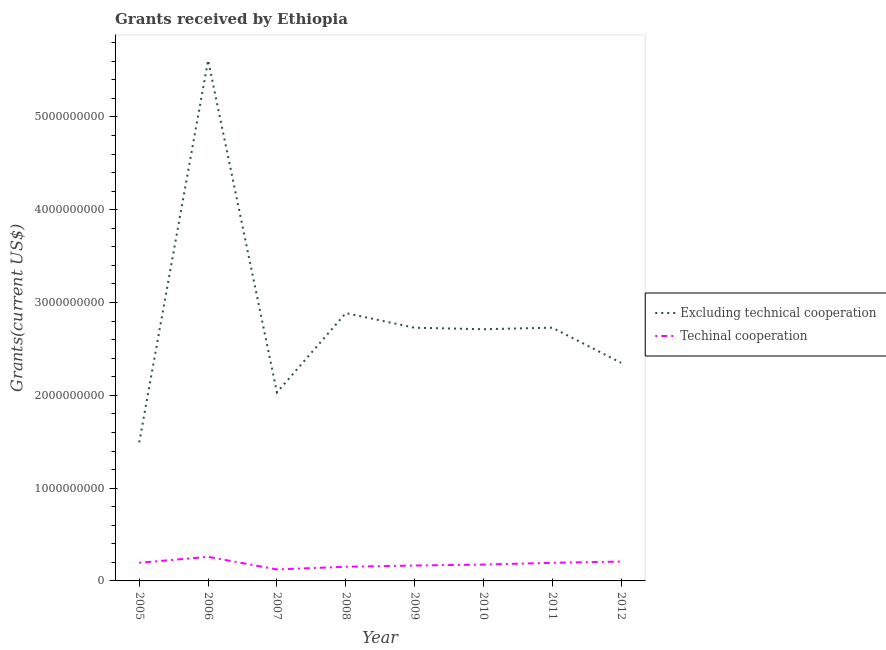What is the amount of grants received(including technical cooperation) in 2005?
Ensure brevity in your answer.  1.96e+08. Across all years, what is the maximum amount of grants received(including technical cooperation)?
Your response must be concise. 2.59e+08. Across all years, what is the minimum amount of grants received(including technical cooperation)?
Give a very brief answer. 1.24e+08. In which year was the amount of grants received(including technical cooperation) minimum?
Ensure brevity in your answer.  2007. What is the total amount of grants received(including technical cooperation) in the graph?
Your response must be concise. 1.48e+09. What is the difference between the amount of grants received(excluding technical cooperation) in 2006 and that in 2007?
Give a very brief answer. 3.58e+09. What is the difference between the amount of grants received(including technical cooperation) in 2005 and the amount of grants received(excluding technical cooperation) in 2008?
Give a very brief answer. -2.69e+09. What is the average amount of grants received(excluding technical cooperation) per year?
Your response must be concise. 2.82e+09. In the year 2010, what is the difference between the amount of grants received(excluding technical cooperation) and amount of grants received(including technical cooperation)?
Your answer should be compact. 2.54e+09. In how many years, is the amount of grants received(including technical cooperation) greater than 1000000000 US$?
Offer a terse response. 0. What is the ratio of the amount of grants received(excluding technical cooperation) in 2010 to that in 2012?
Provide a succinct answer. 1.15. Is the amount of grants received(including technical cooperation) in 2006 less than that in 2009?
Ensure brevity in your answer.  No. What is the difference between the highest and the second highest amount of grants received(excluding technical cooperation)?
Provide a short and direct response. 2.72e+09. What is the difference between the highest and the lowest amount of grants received(including technical cooperation)?
Offer a very short reply. 1.35e+08. Does the amount of grants received(excluding technical cooperation) monotonically increase over the years?
Provide a short and direct response. No. Is the amount of grants received(including technical cooperation) strictly greater than the amount of grants received(excluding technical cooperation) over the years?
Your response must be concise. No. Is the amount of grants received(excluding technical cooperation) strictly less than the amount of grants received(including technical cooperation) over the years?
Your answer should be very brief. No. How many lines are there?
Make the answer very short. 2. How many years are there in the graph?
Ensure brevity in your answer.  8. What is the difference between two consecutive major ticks on the Y-axis?
Ensure brevity in your answer.  1.00e+09. Are the values on the major ticks of Y-axis written in scientific E-notation?
Your answer should be compact. No. Does the graph contain grids?
Keep it short and to the point. No. How are the legend labels stacked?
Your response must be concise. Vertical. What is the title of the graph?
Your answer should be very brief. Grants received by Ethiopia. Does "Resident workers" appear as one of the legend labels in the graph?
Your answer should be compact. No. What is the label or title of the X-axis?
Offer a very short reply. Year. What is the label or title of the Y-axis?
Your response must be concise. Grants(current US$). What is the Grants(current US$) of Excluding technical cooperation in 2005?
Offer a terse response. 1.49e+09. What is the Grants(current US$) in Techinal cooperation in 2005?
Provide a short and direct response. 1.96e+08. What is the Grants(current US$) of Excluding technical cooperation in 2006?
Offer a terse response. 5.61e+09. What is the Grants(current US$) in Techinal cooperation in 2006?
Offer a terse response. 2.59e+08. What is the Grants(current US$) of Excluding technical cooperation in 2007?
Offer a very short reply. 2.03e+09. What is the Grants(current US$) of Techinal cooperation in 2007?
Provide a succinct answer. 1.24e+08. What is the Grants(current US$) of Excluding technical cooperation in 2008?
Make the answer very short. 2.89e+09. What is the Grants(current US$) in Techinal cooperation in 2008?
Your answer should be compact. 1.52e+08. What is the Grants(current US$) in Excluding technical cooperation in 2009?
Your answer should be compact. 2.73e+09. What is the Grants(current US$) in Techinal cooperation in 2009?
Provide a short and direct response. 1.66e+08. What is the Grants(current US$) of Excluding technical cooperation in 2010?
Offer a very short reply. 2.71e+09. What is the Grants(current US$) in Techinal cooperation in 2010?
Provide a succinct answer. 1.76e+08. What is the Grants(current US$) of Excluding technical cooperation in 2011?
Keep it short and to the point. 2.73e+09. What is the Grants(current US$) of Techinal cooperation in 2011?
Your response must be concise. 1.95e+08. What is the Grants(current US$) of Excluding technical cooperation in 2012?
Your response must be concise. 2.35e+09. What is the Grants(current US$) of Techinal cooperation in 2012?
Your answer should be compact. 2.09e+08. Across all years, what is the maximum Grants(current US$) in Excluding technical cooperation?
Make the answer very short. 5.61e+09. Across all years, what is the maximum Grants(current US$) of Techinal cooperation?
Ensure brevity in your answer.  2.59e+08. Across all years, what is the minimum Grants(current US$) of Excluding technical cooperation?
Provide a succinct answer. 1.49e+09. Across all years, what is the minimum Grants(current US$) of Techinal cooperation?
Offer a terse response. 1.24e+08. What is the total Grants(current US$) of Excluding technical cooperation in the graph?
Your answer should be compact. 2.25e+1. What is the total Grants(current US$) of Techinal cooperation in the graph?
Your answer should be compact. 1.48e+09. What is the difference between the Grants(current US$) of Excluding technical cooperation in 2005 and that in 2006?
Keep it short and to the point. -4.12e+09. What is the difference between the Grants(current US$) in Techinal cooperation in 2005 and that in 2006?
Your response must be concise. -6.37e+07. What is the difference between the Grants(current US$) of Excluding technical cooperation in 2005 and that in 2007?
Your answer should be compact. -5.38e+08. What is the difference between the Grants(current US$) in Techinal cooperation in 2005 and that in 2007?
Ensure brevity in your answer.  7.18e+07. What is the difference between the Grants(current US$) in Excluding technical cooperation in 2005 and that in 2008?
Provide a short and direct response. -1.39e+09. What is the difference between the Grants(current US$) of Techinal cooperation in 2005 and that in 2008?
Your response must be concise. 4.32e+07. What is the difference between the Grants(current US$) in Excluding technical cooperation in 2005 and that in 2009?
Your response must be concise. -1.23e+09. What is the difference between the Grants(current US$) in Techinal cooperation in 2005 and that in 2009?
Ensure brevity in your answer.  2.97e+07. What is the difference between the Grants(current US$) in Excluding technical cooperation in 2005 and that in 2010?
Make the answer very short. -1.22e+09. What is the difference between the Grants(current US$) of Techinal cooperation in 2005 and that in 2010?
Offer a terse response. 1.97e+07. What is the difference between the Grants(current US$) of Excluding technical cooperation in 2005 and that in 2011?
Make the answer very short. -1.24e+09. What is the difference between the Grants(current US$) in Techinal cooperation in 2005 and that in 2011?
Your response must be concise. 5.60e+05. What is the difference between the Grants(current US$) in Excluding technical cooperation in 2005 and that in 2012?
Give a very brief answer. -8.56e+08. What is the difference between the Grants(current US$) of Techinal cooperation in 2005 and that in 2012?
Offer a very short reply. -1.30e+07. What is the difference between the Grants(current US$) of Excluding technical cooperation in 2006 and that in 2007?
Your answer should be compact. 3.58e+09. What is the difference between the Grants(current US$) in Techinal cooperation in 2006 and that in 2007?
Offer a terse response. 1.35e+08. What is the difference between the Grants(current US$) of Excluding technical cooperation in 2006 and that in 2008?
Keep it short and to the point. 2.72e+09. What is the difference between the Grants(current US$) in Techinal cooperation in 2006 and that in 2008?
Keep it short and to the point. 1.07e+08. What is the difference between the Grants(current US$) of Excluding technical cooperation in 2006 and that in 2009?
Your answer should be very brief. 2.88e+09. What is the difference between the Grants(current US$) in Techinal cooperation in 2006 and that in 2009?
Keep it short and to the point. 9.34e+07. What is the difference between the Grants(current US$) in Excluding technical cooperation in 2006 and that in 2010?
Make the answer very short. 2.90e+09. What is the difference between the Grants(current US$) in Techinal cooperation in 2006 and that in 2010?
Offer a terse response. 8.34e+07. What is the difference between the Grants(current US$) in Excluding technical cooperation in 2006 and that in 2011?
Give a very brief answer. 2.88e+09. What is the difference between the Grants(current US$) of Techinal cooperation in 2006 and that in 2011?
Ensure brevity in your answer.  6.43e+07. What is the difference between the Grants(current US$) of Excluding technical cooperation in 2006 and that in 2012?
Ensure brevity in your answer.  3.26e+09. What is the difference between the Grants(current US$) of Techinal cooperation in 2006 and that in 2012?
Give a very brief answer. 5.08e+07. What is the difference between the Grants(current US$) in Excluding technical cooperation in 2007 and that in 2008?
Keep it short and to the point. -8.54e+08. What is the difference between the Grants(current US$) of Techinal cooperation in 2007 and that in 2008?
Your response must be concise. -2.85e+07. What is the difference between the Grants(current US$) in Excluding technical cooperation in 2007 and that in 2009?
Offer a very short reply. -6.97e+08. What is the difference between the Grants(current US$) of Techinal cooperation in 2007 and that in 2009?
Provide a short and direct response. -4.20e+07. What is the difference between the Grants(current US$) in Excluding technical cooperation in 2007 and that in 2010?
Ensure brevity in your answer.  -6.81e+08. What is the difference between the Grants(current US$) of Techinal cooperation in 2007 and that in 2010?
Your answer should be compact. -5.21e+07. What is the difference between the Grants(current US$) in Excluding technical cooperation in 2007 and that in 2011?
Keep it short and to the point. -6.97e+08. What is the difference between the Grants(current US$) in Techinal cooperation in 2007 and that in 2011?
Offer a terse response. -7.12e+07. What is the difference between the Grants(current US$) of Excluding technical cooperation in 2007 and that in 2012?
Your answer should be compact. -3.18e+08. What is the difference between the Grants(current US$) in Techinal cooperation in 2007 and that in 2012?
Ensure brevity in your answer.  -8.47e+07. What is the difference between the Grants(current US$) in Excluding technical cooperation in 2008 and that in 2009?
Keep it short and to the point. 1.58e+08. What is the difference between the Grants(current US$) of Techinal cooperation in 2008 and that in 2009?
Make the answer very short. -1.35e+07. What is the difference between the Grants(current US$) in Excluding technical cooperation in 2008 and that in 2010?
Your response must be concise. 1.74e+08. What is the difference between the Grants(current US$) of Techinal cooperation in 2008 and that in 2010?
Give a very brief answer. -2.36e+07. What is the difference between the Grants(current US$) in Excluding technical cooperation in 2008 and that in 2011?
Your answer should be compact. 1.57e+08. What is the difference between the Grants(current US$) of Techinal cooperation in 2008 and that in 2011?
Give a very brief answer. -4.27e+07. What is the difference between the Grants(current US$) in Excluding technical cooperation in 2008 and that in 2012?
Make the answer very short. 5.36e+08. What is the difference between the Grants(current US$) of Techinal cooperation in 2008 and that in 2012?
Your response must be concise. -5.62e+07. What is the difference between the Grants(current US$) in Excluding technical cooperation in 2009 and that in 2010?
Offer a very short reply. 1.60e+07. What is the difference between the Grants(current US$) in Techinal cooperation in 2009 and that in 2010?
Provide a succinct answer. -1.00e+07. What is the difference between the Grants(current US$) of Excluding technical cooperation in 2009 and that in 2011?
Offer a very short reply. -6.20e+05. What is the difference between the Grants(current US$) in Techinal cooperation in 2009 and that in 2011?
Ensure brevity in your answer.  -2.92e+07. What is the difference between the Grants(current US$) of Excluding technical cooperation in 2009 and that in 2012?
Offer a very short reply. 3.79e+08. What is the difference between the Grants(current US$) of Techinal cooperation in 2009 and that in 2012?
Keep it short and to the point. -4.27e+07. What is the difference between the Grants(current US$) of Excluding technical cooperation in 2010 and that in 2011?
Make the answer very short. -1.66e+07. What is the difference between the Grants(current US$) of Techinal cooperation in 2010 and that in 2011?
Offer a very short reply. -1.91e+07. What is the difference between the Grants(current US$) in Excluding technical cooperation in 2010 and that in 2012?
Make the answer very short. 3.63e+08. What is the difference between the Grants(current US$) of Techinal cooperation in 2010 and that in 2012?
Make the answer very short. -3.27e+07. What is the difference between the Grants(current US$) of Excluding technical cooperation in 2011 and that in 2012?
Make the answer very short. 3.79e+08. What is the difference between the Grants(current US$) in Techinal cooperation in 2011 and that in 2012?
Keep it short and to the point. -1.35e+07. What is the difference between the Grants(current US$) of Excluding technical cooperation in 2005 and the Grants(current US$) of Techinal cooperation in 2006?
Your answer should be very brief. 1.23e+09. What is the difference between the Grants(current US$) of Excluding technical cooperation in 2005 and the Grants(current US$) of Techinal cooperation in 2007?
Ensure brevity in your answer.  1.37e+09. What is the difference between the Grants(current US$) of Excluding technical cooperation in 2005 and the Grants(current US$) of Techinal cooperation in 2008?
Your response must be concise. 1.34e+09. What is the difference between the Grants(current US$) of Excluding technical cooperation in 2005 and the Grants(current US$) of Techinal cooperation in 2009?
Ensure brevity in your answer.  1.33e+09. What is the difference between the Grants(current US$) of Excluding technical cooperation in 2005 and the Grants(current US$) of Techinal cooperation in 2010?
Offer a very short reply. 1.32e+09. What is the difference between the Grants(current US$) in Excluding technical cooperation in 2005 and the Grants(current US$) in Techinal cooperation in 2011?
Give a very brief answer. 1.30e+09. What is the difference between the Grants(current US$) of Excluding technical cooperation in 2005 and the Grants(current US$) of Techinal cooperation in 2012?
Offer a very short reply. 1.28e+09. What is the difference between the Grants(current US$) of Excluding technical cooperation in 2006 and the Grants(current US$) of Techinal cooperation in 2007?
Make the answer very short. 5.49e+09. What is the difference between the Grants(current US$) of Excluding technical cooperation in 2006 and the Grants(current US$) of Techinal cooperation in 2008?
Give a very brief answer. 5.46e+09. What is the difference between the Grants(current US$) in Excluding technical cooperation in 2006 and the Grants(current US$) in Techinal cooperation in 2009?
Offer a terse response. 5.44e+09. What is the difference between the Grants(current US$) in Excluding technical cooperation in 2006 and the Grants(current US$) in Techinal cooperation in 2010?
Offer a very short reply. 5.43e+09. What is the difference between the Grants(current US$) of Excluding technical cooperation in 2006 and the Grants(current US$) of Techinal cooperation in 2011?
Provide a short and direct response. 5.42e+09. What is the difference between the Grants(current US$) in Excluding technical cooperation in 2006 and the Grants(current US$) in Techinal cooperation in 2012?
Keep it short and to the point. 5.40e+09. What is the difference between the Grants(current US$) in Excluding technical cooperation in 2007 and the Grants(current US$) in Techinal cooperation in 2008?
Make the answer very short. 1.88e+09. What is the difference between the Grants(current US$) in Excluding technical cooperation in 2007 and the Grants(current US$) in Techinal cooperation in 2009?
Offer a very short reply. 1.87e+09. What is the difference between the Grants(current US$) of Excluding technical cooperation in 2007 and the Grants(current US$) of Techinal cooperation in 2010?
Provide a short and direct response. 1.86e+09. What is the difference between the Grants(current US$) of Excluding technical cooperation in 2007 and the Grants(current US$) of Techinal cooperation in 2011?
Provide a short and direct response. 1.84e+09. What is the difference between the Grants(current US$) in Excluding technical cooperation in 2007 and the Grants(current US$) in Techinal cooperation in 2012?
Give a very brief answer. 1.82e+09. What is the difference between the Grants(current US$) in Excluding technical cooperation in 2008 and the Grants(current US$) in Techinal cooperation in 2009?
Provide a short and direct response. 2.72e+09. What is the difference between the Grants(current US$) in Excluding technical cooperation in 2008 and the Grants(current US$) in Techinal cooperation in 2010?
Your answer should be compact. 2.71e+09. What is the difference between the Grants(current US$) in Excluding technical cooperation in 2008 and the Grants(current US$) in Techinal cooperation in 2011?
Offer a very short reply. 2.69e+09. What is the difference between the Grants(current US$) of Excluding technical cooperation in 2008 and the Grants(current US$) of Techinal cooperation in 2012?
Offer a terse response. 2.68e+09. What is the difference between the Grants(current US$) in Excluding technical cooperation in 2009 and the Grants(current US$) in Techinal cooperation in 2010?
Offer a terse response. 2.55e+09. What is the difference between the Grants(current US$) in Excluding technical cooperation in 2009 and the Grants(current US$) in Techinal cooperation in 2011?
Keep it short and to the point. 2.53e+09. What is the difference between the Grants(current US$) in Excluding technical cooperation in 2009 and the Grants(current US$) in Techinal cooperation in 2012?
Provide a short and direct response. 2.52e+09. What is the difference between the Grants(current US$) of Excluding technical cooperation in 2010 and the Grants(current US$) of Techinal cooperation in 2011?
Offer a terse response. 2.52e+09. What is the difference between the Grants(current US$) in Excluding technical cooperation in 2010 and the Grants(current US$) in Techinal cooperation in 2012?
Make the answer very short. 2.50e+09. What is the difference between the Grants(current US$) in Excluding technical cooperation in 2011 and the Grants(current US$) in Techinal cooperation in 2012?
Provide a short and direct response. 2.52e+09. What is the average Grants(current US$) of Excluding technical cooperation per year?
Ensure brevity in your answer.  2.82e+09. What is the average Grants(current US$) of Techinal cooperation per year?
Give a very brief answer. 1.85e+08. In the year 2005, what is the difference between the Grants(current US$) in Excluding technical cooperation and Grants(current US$) in Techinal cooperation?
Offer a terse response. 1.30e+09. In the year 2006, what is the difference between the Grants(current US$) of Excluding technical cooperation and Grants(current US$) of Techinal cooperation?
Keep it short and to the point. 5.35e+09. In the year 2007, what is the difference between the Grants(current US$) of Excluding technical cooperation and Grants(current US$) of Techinal cooperation?
Keep it short and to the point. 1.91e+09. In the year 2008, what is the difference between the Grants(current US$) of Excluding technical cooperation and Grants(current US$) of Techinal cooperation?
Give a very brief answer. 2.73e+09. In the year 2009, what is the difference between the Grants(current US$) of Excluding technical cooperation and Grants(current US$) of Techinal cooperation?
Provide a short and direct response. 2.56e+09. In the year 2010, what is the difference between the Grants(current US$) in Excluding technical cooperation and Grants(current US$) in Techinal cooperation?
Ensure brevity in your answer.  2.54e+09. In the year 2011, what is the difference between the Grants(current US$) of Excluding technical cooperation and Grants(current US$) of Techinal cooperation?
Provide a succinct answer. 2.53e+09. In the year 2012, what is the difference between the Grants(current US$) in Excluding technical cooperation and Grants(current US$) in Techinal cooperation?
Make the answer very short. 2.14e+09. What is the ratio of the Grants(current US$) of Excluding technical cooperation in 2005 to that in 2006?
Offer a terse response. 0.27. What is the ratio of the Grants(current US$) of Techinal cooperation in 2005 to that in 2006?
Your answer should be very brief. 0.75. What is the ratio of the Grants(current US$) in Excluding technical cooperation in 2005 to that in 2007?
Keep it short and to the point. 0.74. What is the ratio of the Grants(current US$) in Techinal cooperation in 2005 to that in 2007?
Give a very brief answer. 1.58. What is the ratio of the Grants(current US$) in Excluding technical cooperation in 2005 to that in 2008?
Your answer should be very brief. 0.52. What is the ratio of the Grants(current US$) in Techinal cooperation in 2005 to that in 2008?
Your response must be concise. 1.28. What is the ratio of the Grants(current US$) in Excluding technical cooperation in 2005 to that in 2009?
Provide a succinct answer. 0.55. What is the ratio of the Grants(current US$) of Techinal cooperation in 2005 to that in 2009?
Your answer should be compact. 1.18. What is the ratio of the Grants(current US$) of Excluding technical cooperation in 2005 to that in 2010?
Make the answer very short. 0.55. What is the ratio of the Grants(current US$) in Techinal cooperation in 2005 to that in 2010?
Your answer should be compact. 1.11. What is the ratio of the Grants(current US$) of Excluding technical cooperation in 2005 to that in 2011?
Provide a short and direct response. 0.55. What is the ratio of the Grants(current US$) in Excluding technical cooperation in 2005 to that in 2012?
Your answer should be compact. 0.64. What is the ratio of the Grants(current US$) of Techinal cooperation in 2005 to that in 2012?
Give a very brief answer. 0.94. What is the ratio of the Grants(current US$) in Excluding technical cooperation in 2006 to that in 2007?
Keep it short and to the point. 2.76. What is the ratio of the Grants(current US$) in Techinal cooperation in 2006 to that in 2007?
Keep it short and to the point. 2.09. What is the ratio of the Grants(current US$) of Excluding technical cooperation in 2006 to that in 2008?
Your answer should be very brief. 1.94. What is the ratio of the Grants(current US$) of Techinal cooperation in 2006 to that in 2008?
Your answer should be very brief. 1.7. What is the ratio of the Grants(current US$) of Excluding technical cooperation in 2006 to that in 2009?
Provide a succinct answer. 2.06. What is the ratio of the Grants(current US$) in Techinal cooperation in 2006 to that in 2009?
Make the answer very short. 1.56. What is the ratio of the Grants(current US$) in Excluding technical cooperation in 2006 to that in 2010?
Provide a succinct answer. 2.07. What is the ratio of the Grants(current US$) of Techinal cooperation in 2006 to that in 2010?
Offer a terse response. 1.47. What is the ratio of the Grants(current US$) of Excluding technical cooperation in 2006 to that in 2011?
Offer a terse response. 2.06. What is the ratio of the Grants(current US$) of Techinal cooperation in 2006 to that in 2011?
Offer a terse response. 1.33. What is the ratio of the Grants(current US$) of Excluding technical cooperation in 2006 to that in 2012?
Your answer should be very brief. 2.39. What is the ratio of the Grants(current US$) of Techinal cooperation in 2006 to that in 2012?
Make the answer very short. 1.24. What is the ratio of the Grants(current US$) of Excluding technical cooperation in 2007 to that in 2008?
Your response must be concise. 0.7. What is the ratio of the Grants(current US$) in Techinal cooperation in 2007 to that in 2008?
Your answer should be very brief. 0.81. What is the ratio of the Grants(current US$) of Excluding technical cooperation in 2007 to that in 2009?
Your answer should be very brief. 0.74. What is the ratio of the Grants(current US$) in Techinal cooperation in 2007 to that in 2009?
Offer a terse response. 0.75. What is the ratio of the Grants(current US$) of Excluding technical cooperation in 2007 to that in 2010?
Provide a succinct answer. 0.75. What is the ratio of the Grants(current US$) in Techinal cooperation in 2007 to that in 2010?
Your response must be concise. 0.7. What is the ratio of the Grants(current US$) in Excluding technical cooperation in 2007 to that in 2011?
Give a very brief answer. 0.74. What is the ratio of the Grants(current US$) in Techinal cooperation in 2007 to that in 2011?
Your answer should be very brief. 0.64. What is the ratio of the Grants(current US$) of Excluding technical cooperation in 2007 to that in 2012?
Ensure brevity in your answer.  0.86. What is the ratio of the Grants(current US$) of Techinal cooperation in 2007 to that in 2012?
Keep it short and to the point. 0.59. What is the ratio of the Grants(current US$) of Excluding technical cooperation in 2008 to that in 2009?
Your response must be concise. 1.06. What is the ratio of the Grants(current US$) in Techinal cooperation in 2008 to that in 2009?
Give a very brief answer. 0.92. What is the ratio of the Grants(current US$) of Excluding technical cooperation in 2008 to that in 2010?
Provide a short and direct response. 1.06. What is the ratio of the Grants(current US$) of Techinal cooperation in 2008 to that in 2010?
Give a very brief answer. 0.87. What is the ratio of the Grants(current US$) in Excluding technical cooperation in 2008 to that in 2011?
Offer a terse response. 1.06. What is the ratio of the Grants(current US$) of Techinal cooperation in 2008 to that in 2011?
Give a very brief answer. 0.78. What is the ratio of the Grants(current US$) in Excluding technical cooperation in 2008 to that in 2012?
Offer a very short reply. 1.23. What is the ratio of the Grants(current US$) in Techinal cooperation in 2008 to that in 2012?
Your response must be concise. 0.73. What is the ratio of the Grants(current US$) of Excluding technical cooperation in 2009 to that in 2010?
Your answer should be compact. 1.01. What is the ratio of the Grants(current US$) in Techinal cooperation in 2009 to that in 2010?
Your response must be concise. 0.94. What is the ratio of the Grants(current US$) of Excluding technical cooperation in 2009 to that in 2011?
Keep it short and to the point. 1. What is the ratio of the Grants(current US$) in Techinal cooperation in 2009 to that in 2011?
Your response must be concise. 0.85. What is the ratio of the Grants(current US$) in Excluding technical cooperation in 2009 to that in 2012?
Make the answer very short. 1.16. What is the ratio of the Grants(current US$) of Techinal cooperation in 2009 to that in 2012?
Your answer should be compact. 0.8. What is the ratio of the Grants(current US$) in Excluding technical cooperation in 2010 to that in 2011?
Offer a very short reply. 0.99. What is the ratio of the Grants(current US$) of Techinal cooperation in 2010 to that in 2011?
Offer a terse response. 0.9. What is the ratio of the Grants(current US$) of Excluding technical cooperation in 2010 to that in 2012?
Your answer should be very brief. 1.15. What is the ratio of the Grants(current US$) of Techinal cooperation in 2010 to that in 2012?
Ensure brevity in your answer.  0.84. What is the ratio of the Grants(current US$) of Excluding technical cooperation in 2011 to that in 2012?
Offer a very short reply. 1.16. What is the ratio of the Grants(current US$) of Techinal cooperation in 2011 to that in 2012?
Give a very brief answer. 0.94. What is the difference between the highest and the second highest Grants(current US$) of Excluding technical cooperation?
Ensure brevity in your answer.  2.72e+09. What is the difference between the highest and the second highest Grants(current US$) in Techinal cooperation?
Offer a terse response. 5.08e+07. What is the difference between the highest and the lowest Grants(current US$) in Excluding technical cooperation?
Your answer should be compact. 4.12e+09. What is the difference between the highest and the lowest Grants(current US$) in Techinal cooperation?
Offer a terse response. 1.35e+08. 